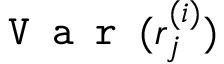Convert formula to latex. <formula><loc_0><loc_0><loc_500><loc_500>V a r ( r _ { j } ^ { ( i ) } )</formula> 